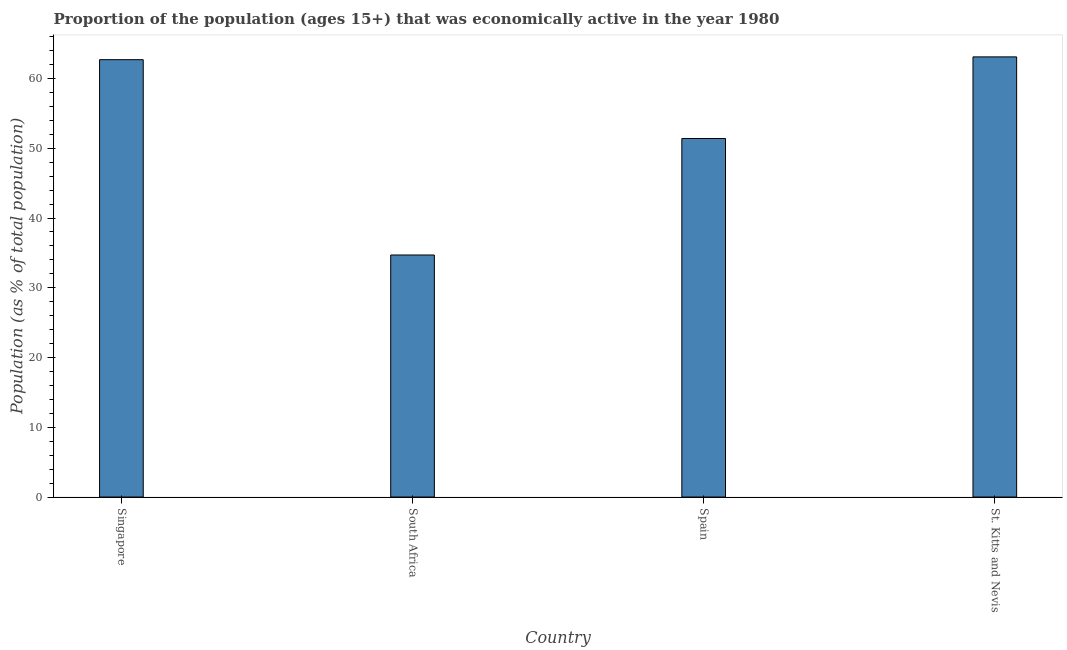Does the graph contain any zero values?
Your response must be concise. No. Does the graph contain grids?
Your answer should be very brief. No. What is the title of the graph?
Ensure brevity in your answer.  Proportion of the population (ages 15+) that was economically active in the year 1980. What is the label or title of the X-axis?
Make the answer very short. Country. What is the label or title of the Y-axis?
Your response must be concise. Population (as % of total population). What is the percentage of economically active population in St. Kitts and Nevis?
Provide a succinct answer. 63.1. Across all countries, what is the maximum percentage of economically active population?
Your response must be concise. 63.1. Across all countries, what is the minimum percentage of economically active population?
Provide a succinct answer. 34.7. In which country was the percentage of economically active population maximum?
Offer a very short reply. St. Kitts and Nevis. In which country was the percentage of economically active population minimum?
Make the answer very short. South Africa. What is the sum of the percentage of economically active population?
Your response must be concise. 211.9. What is the difference between the percentage of economically active population in South Africa and St. Kitts and Nevis?
Make the answer very short. -28.4. What is the average percentage of economically active population per country?
Give a very brief answer. 52.98. What is the median percentage of economically active population?
Your answer should be very brief. 57.05. What is the ratio of the percentage of economically active population in Singapore to that in St. Kitts and Nevis?
Ensure brevity in your answer.  0.99. What is the difference between the highest and the second highest percentage of economically active population?
Keep it short and to the point. 0.4. Is the sum of the percentage of economically active population in Singapore and St. Kitts and Nevis greater than the maximum percentage of economically active population across all countries?
Offer a terse response. Yes. What is the difference between the highest and the lowest percentage of economically active population?
Make the answer very short. 28.4. Are all the bars in the graph horizontal?
Make the answer very short. No. How many countries are there in the graph?
Provide a short and direct response. 4. Are the values on the major ticks of Y-axis written in scientific E-notation?
Your answer should be very brief. No. What is the Population (as % of total population) in Singapore?
Give a very brief answer. 62.7. What is the Population (as % of total population) of South Africa?
Offer a very short reply. 34.7. What is the Population (as % of total population) of Spain?
Ensure brevity in your answer.  51.4. What is the Population (as % of total population) of St. Kitts and Nevis?
Give a very brief answer. 63.1. What is the difference between the Population (as % of total population) in Singapore and Spain?
Offer a very short reply. 11.3. What is the difference between the Population (as % of total population) in Singapore and St. Kitts and Nevis?
Provide a succinct answer. -0.4. What is the difference between the Population (as % of total population) in South Africa and Spain?
Offer a terse response. -16.7. What is the difference between the Population (as % of total population) in South Africa and St. Kitts and Nevis?
Your answer should be compact. -28.4. What is the difference between the Population (as % of total population) in Spain and St. Kitts and Nevis?
Offer a terse response. -11.7. What is the ratio of the Population (as % of total population) in Singapore to that in South Africa?
Provide a short and direct response. 1.81. What is the ratio of the Population (as % of total population) in Singapore to that in Spain?
Provide a short and direct response. 1.22. What is the ratio of the Population (as % of total population) in Singapore to that in St. Kitts and Nevis?
Your answer should be very brief. 0.99. What is the ratio of the Population (as % of total population) in South Africa to that in Spain?
Offer a terse response. 0.68. What is the ratio of the Population (as % of total population) in South Africa to that in St. Kitts and Nevis?
Your answer should be very brief. 0.55. What is the ratio of the Population (as % of total population) in Spain to that in St. Kitts and Nevis?
Provide a short and direct response. 0.81. 